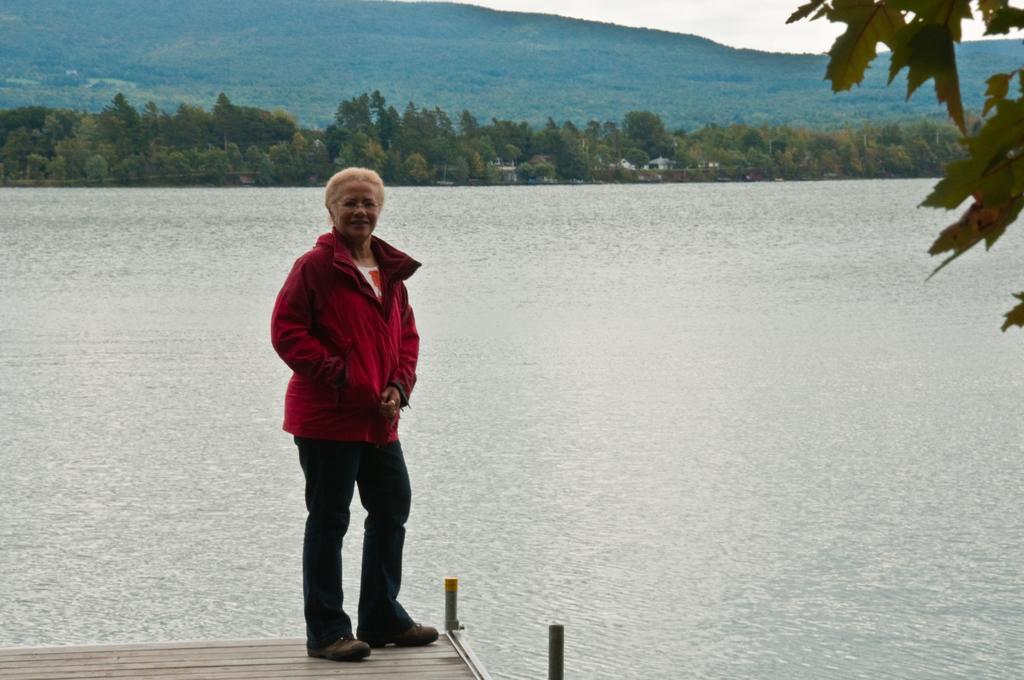In one or two sentences, can you explain what this image depicts? There is a woman standing on the surface and we can see water,right side of the image we can see leaves. In the background we can see trees,hills and sky. 